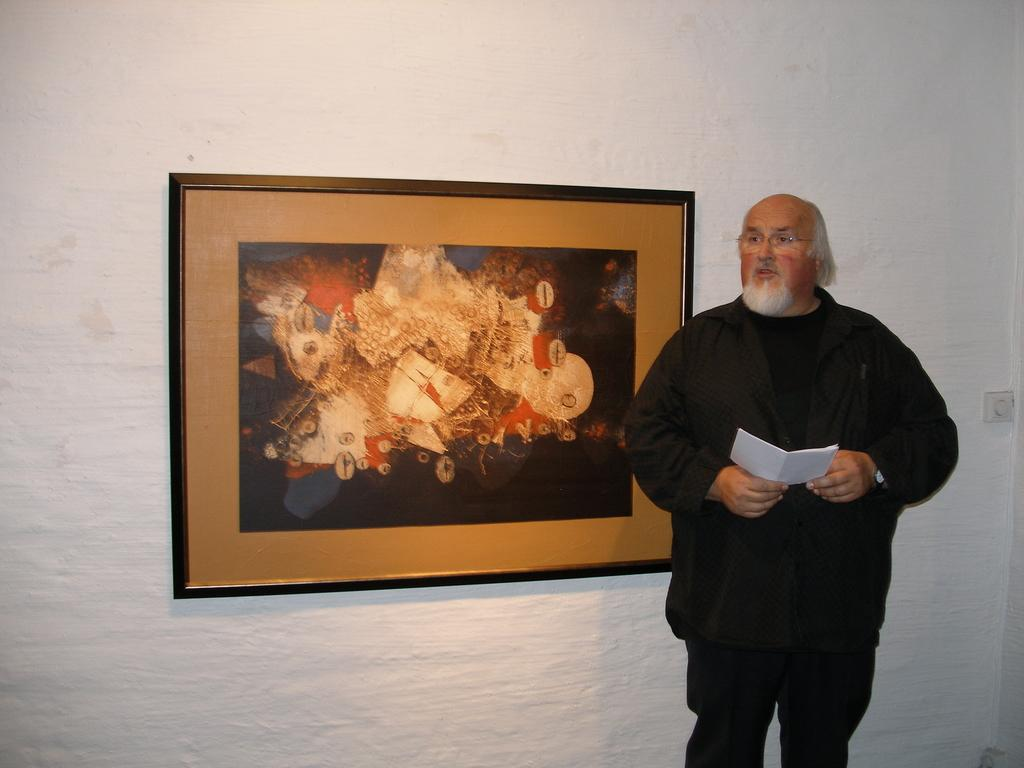What is the main subject of the picture? The main subject of the picture is a man. What is the man doing in the picture? The man is standing in the picture. What is the man holding in his hands? The man is holding a book in his hands. What can be seen on the wall in the background? There is a photo on a white color wall in the background. What is depicted in the photo on the wall? The photo contains some art design. What type of advertisement can be seen on the wall in the image? There is no advertisement present in the image; it features a photo with an art design on the wall. What kind of pain is the man experiencing in the image? There is no indication of pain in the image; the man is simply standing and holding a book. 